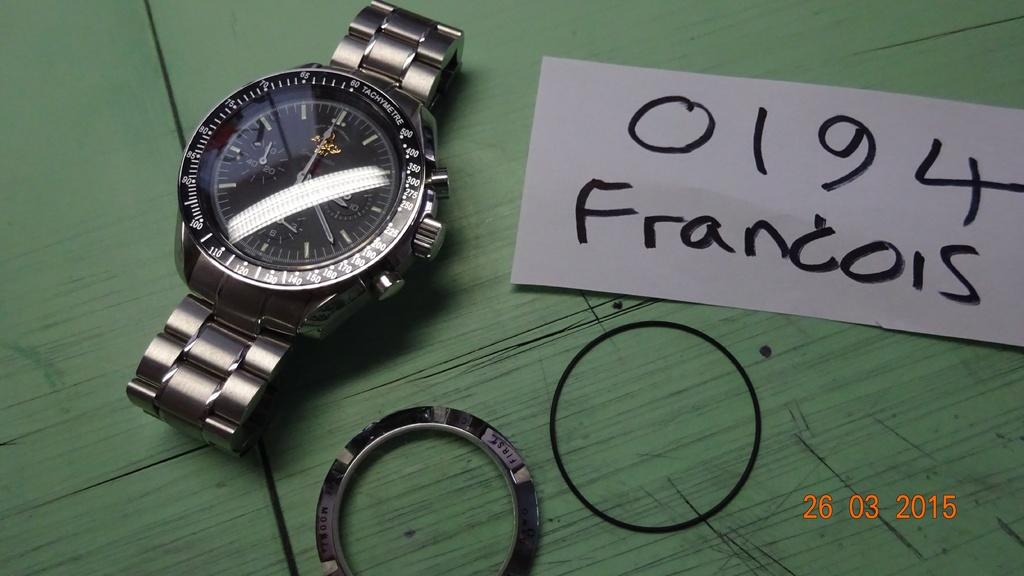What year is this taken?
Offer a very short reply. 2015. 